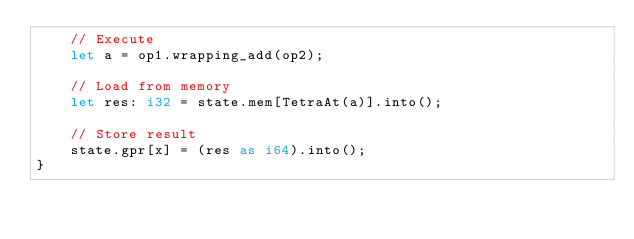Convert code to text. <code><loc_0><loc_0><loc_500><loc_500><_Rust_>    // Execute
    let a = op1.wrapping_add(op2);

    // Load from memory
    let res: i32 = state.mem[TetraAt(a)].into();

    // Store result
    state.gpr[x] = (res as i64).into();
}
</code> 